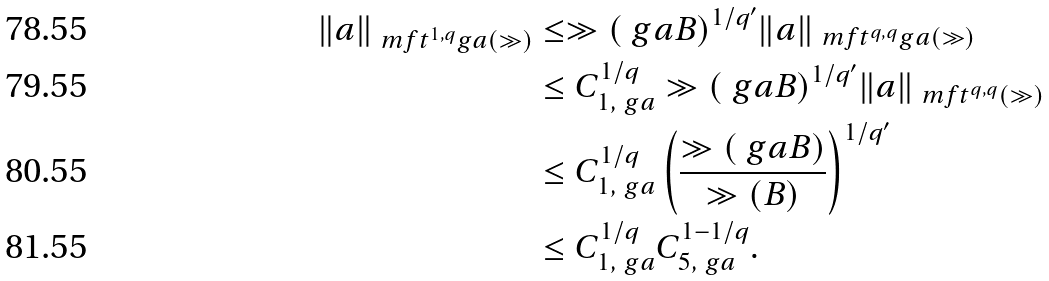Convert formula to latex. <formula><loc_0><loc_0><loc_500><loc_500>\| a \| _ { \ m f { t } ^ { 1 , q } _ { \ } g a ( \gg ) } & \leq \gg ( \ g a B ) ^ { 1 / { q ^ { \prime } } } \| a \| _ { \ m f { t } ^ { q , q } _ { \ } g a ( \gg ) } \\ & \leq C _ { 1 , \ g a } ^ { 1 / q } \gg ( \ g a B ) ^ { 1 / q ^ { \prime } } \| a \| _ { \ m f { t } ^ { q , q } ( \gg ) } \\ & \leq C _ { 1 , \ g a } ^ { 1 / q } \left ( \frac { \gg ( \ g a B ) } { \gg ( B ) } \right ) ^ { 1 / q ^ { \prime } } \\ & \leq C _ { 1 , \ g a } ^ { 1 / q } C _ { 5 , \ g a } ^ { 1 - 1 / q } .</formula> 